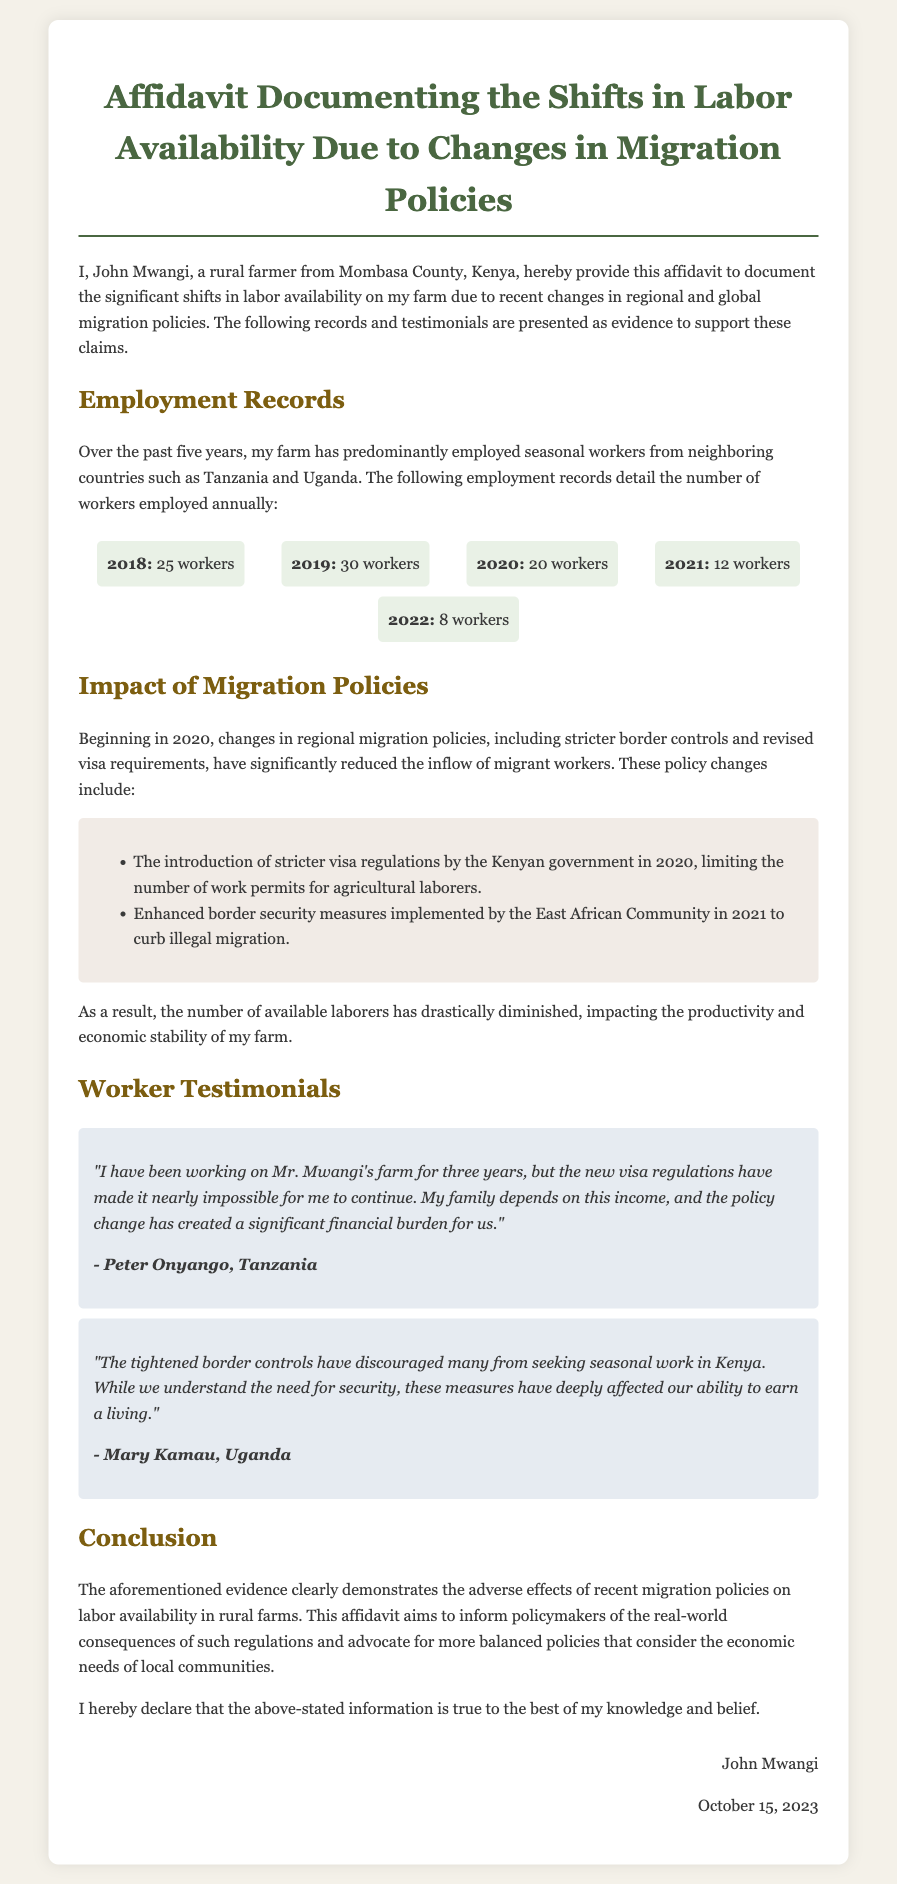What is the name of the farmer providing the affidavit? The document states that the farmer providing the affidavit is named John Mwangi.
Answer: John Mwangi In which county is John Mwangi's farm located? The affidavit mentions that John Mwangi's farm is located in Mombasa County, Kenya.
Answer: Mombasa County How many workers were employed in 2021? The employment records in the document show that there were 12 workers employed in 2021.
Answer: 12 workers What significant policy change occurred in 2020? The document indicates that in 2020, the Kenyan government introduced stricter visa regulations limiting work permits for agricultural laborers.
Answer: Stricter visa regulations Which organizations implemented enhanced border security measures in 2021? According to the affidavit, the East African Community implemented enhanced border security measures in 2021.
Answer: East African Community How many workers were employed on the farm in 2022? The document states that there were 8 workers employed in 2022.
Answer: 8 workers What is the main purpose of this affidavit? The affidavit aims to inform policymakers about the adverse effects of migration policies on labor availability in rural farms.
Answer: To inform policymakers Who is one of the workers providing a testimonial? The document includes a testimonial from Peter Onyango, who is mentioned as a worker.
Answer: Peter Onyango What financial impact does Peter Onyango mention? Peter Onyango states that the policy change has created a significant financial burden for his family.
Answer: Significant financial burden 